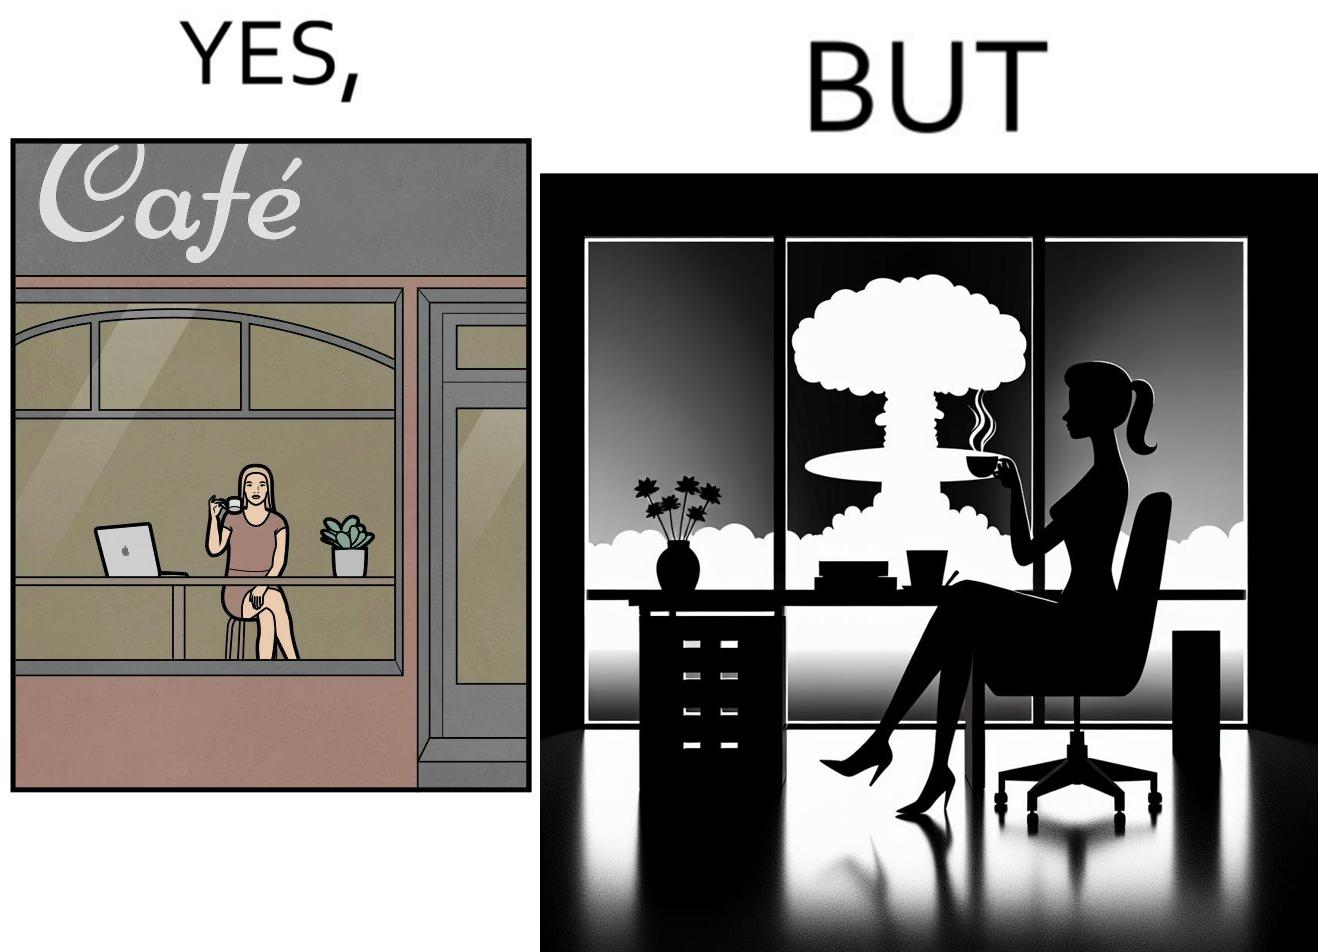Is this image satirical or non-satirical? Yes, this image is satirical. 